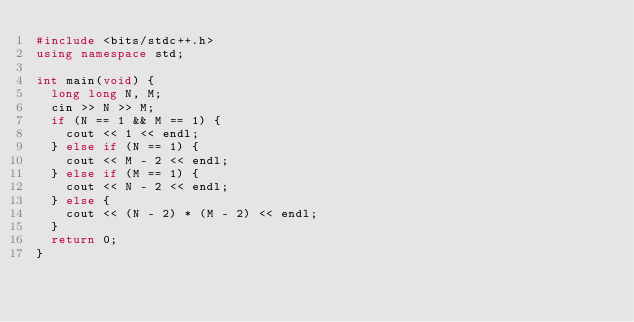<code> <loc_0><loc_0><loc_500><loc_500><_C++_>#include <bits/stdc++.h>
using namespace std;

int main(void) {
  long long N, M;
  cin >> N >> M;
  if (N == 1 && M == 1) {
    cout << 1 << endl;
  } else if (N == 1) {
    cout << M - 2 << endl;
  } else if (M == 1) {
    cout << N - 2 << endl;
  } else {
    cout << (N - 2) * (M - 2) << endl;
  }
  return 0;
}</code> 